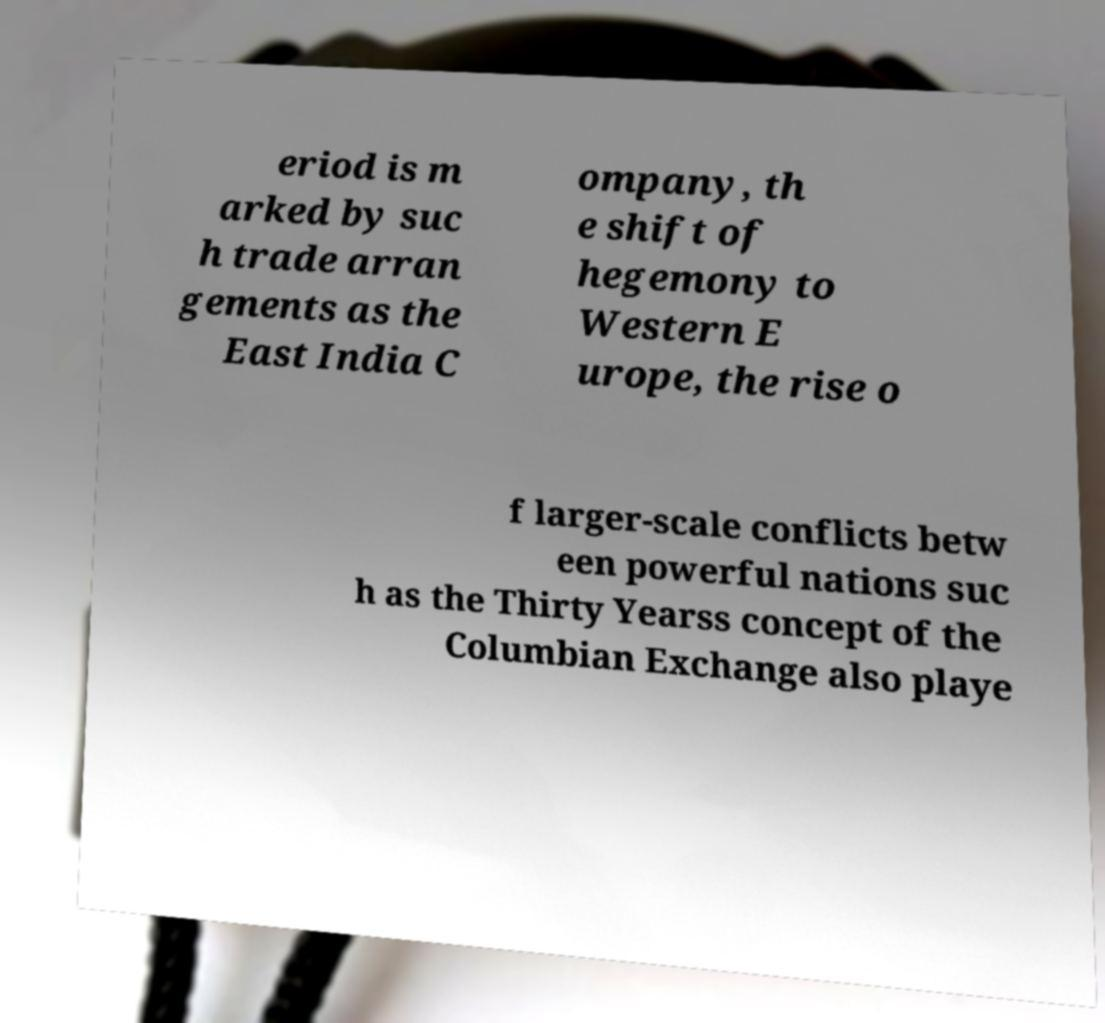Please identify and transcribe the text found in this image. eriod is m arked by suc h trade arran gements as the East India C ompany, th e shift of hegemony to Western E urope, the rise o f larger-scale conflicts betw een powerful nations suc h as the Thirty Yearss concept of the Columbian Exchange also playe 